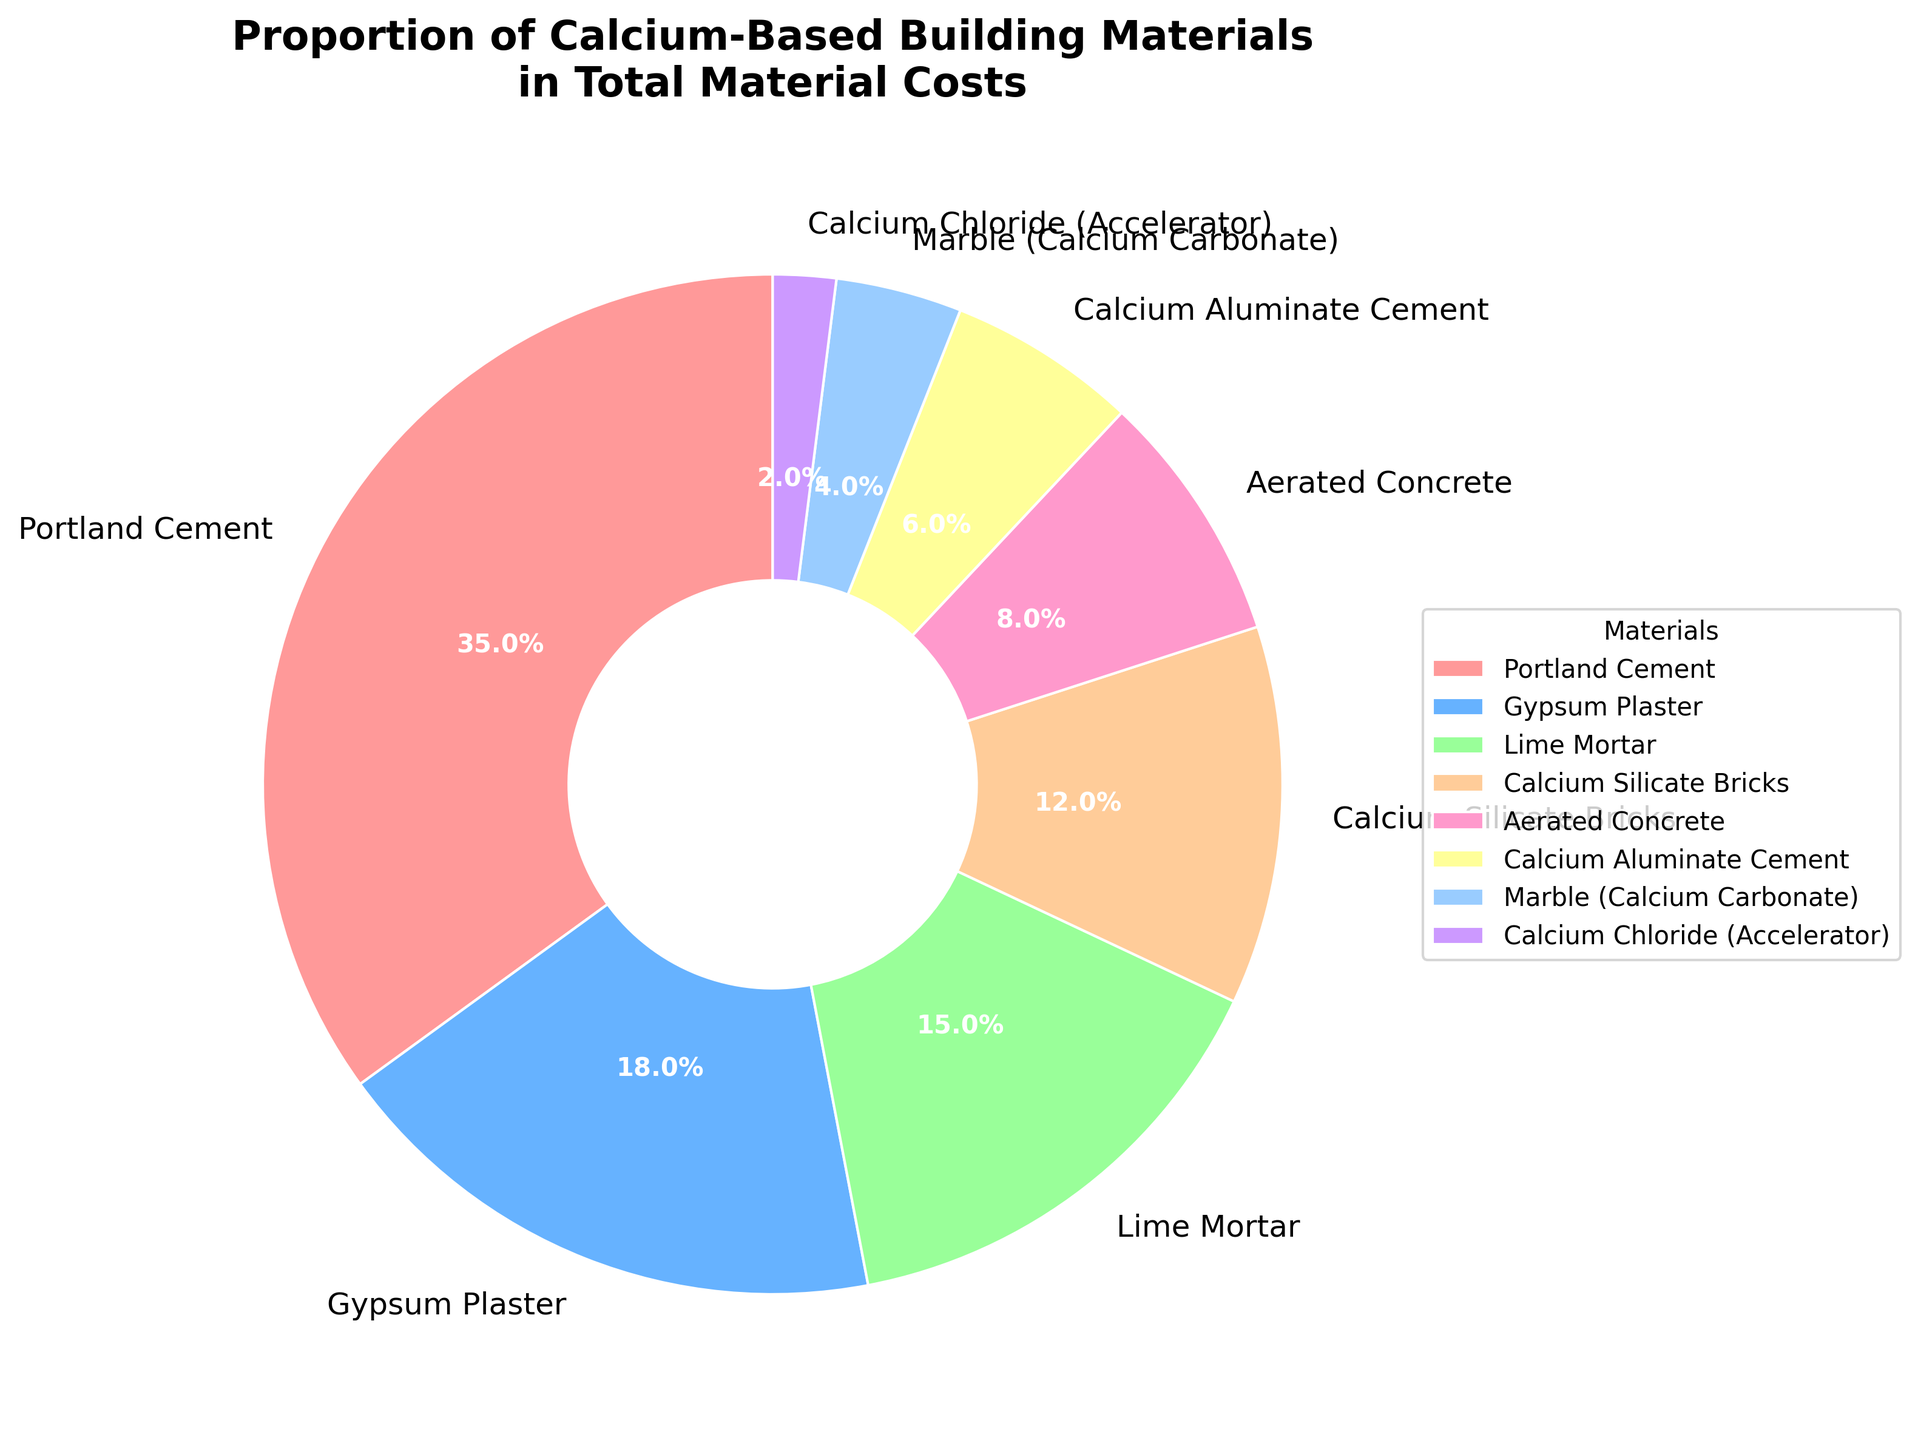what's the total percentage of Portland Cement and Gypsum Plaster combined? First, identify the percentage of Portland Cement (35%) and Gypsum Plaster (18%). Then sum these values: 35 + 18 = 53
Answer: 53% which material has the smallest proportion in the total material costs? Observe the pie chart and identify the material with the smallest percentage, which is Calcium Chloride (Accelerator) with 2%
Answer: Calcium Chloride (Accelerator) how much larger is the percentage of Portland Cement compared to Aerated Concrete? Identify the percentage of Portland Cement (35%) and Aerated Concrete (8%). Subtract the smaller percentage from the larger one: 35 - 8 = 27
Answer: 27% which materials have a higher percentage than Lime Mortar? Lime Mortar's percentage is 15%. Look at the pie chart and identify materials with a higher percentage: Portland Cement (35%) and Gypsum Plaster (18%)
Answer: Portland Cement, Gypsum Plaster if you combine Lime Mortar, Calcium Silicate Bricks, and Aerated Concrete, what is their total percentage? Identify the percentages: Lime Mortar (15%), Calcium Silicate Bricks (12%), and Aerated Concrete (8%). Sum these values: 15 + 12 + 8 = 35
Answer: 35% how many materials have a percentage less than or equal to 10%? Identify materials with percentages less than or equal to 10%: Aerated Concrete (8%), Calcium Aluminate Cement (6%), Marble (Calcium Carbonate) (4%), and Calcium Chloride (Accelerator) (2%). There are four such materials.
Answer: 4 which two materials, when combined, account for approximately one-third of the total percentage? One-third of 100% is approximately 33%. Identify the percentages for each material and find two that sum to around 33%. Gypsum Plaster (18%) and Lime Mortar (15%) combined give 18 + 15 = 33, which is close to one-third.
Answer: Gypsum Plaster, Lime Mortar of the materials that have a percentage less than 10%, which one has the highest percentage? Examine the materials with percentages less than 10%: Aerated Concrete (8%), Calcium Aluminate Cement (6%), Marble (Calcium Carbonate) (4%), and Calcium Chloride (Accelerator) (2%). Aerated Concrete has the highest percentage among these.
Answer: Aerated Concrete 